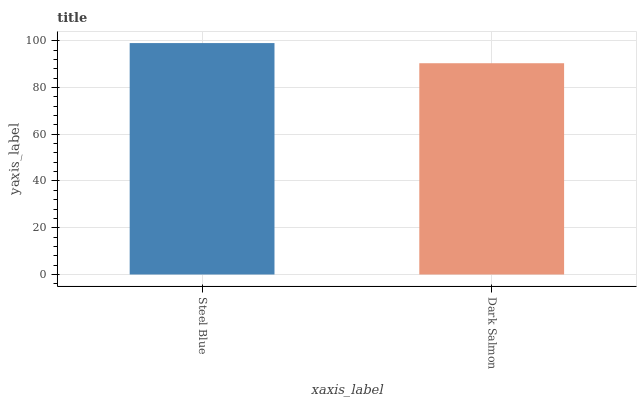Is Dark Salmon the minimum?
Answer yes or no. Yes. Is Steel Blue the maximum?
Answer yes or no. Yes. Is Dark Salmon the maximum?
Answer yes or no. No. Is Steel Blue greater than Dark Salmon?
Answer yes or no. Yes. Is Dark Salmon less than Steel Blue?
Answer yes or no. Yes. Is Dark Salmon greater than Steel Blue?
Answer yes or no. No. Is Steel Blue less than Dark Salmon?
Answer yes or no. No. Is Steel Blue the high median?
Answer yes or no. Yes. Is Dark Salmon the low median?
Answer yes or no. Yes. Is Dark Salmon the high median?
Answer yes or no. No. Is Steel Blue the low median?
Answer yes or no. No. 